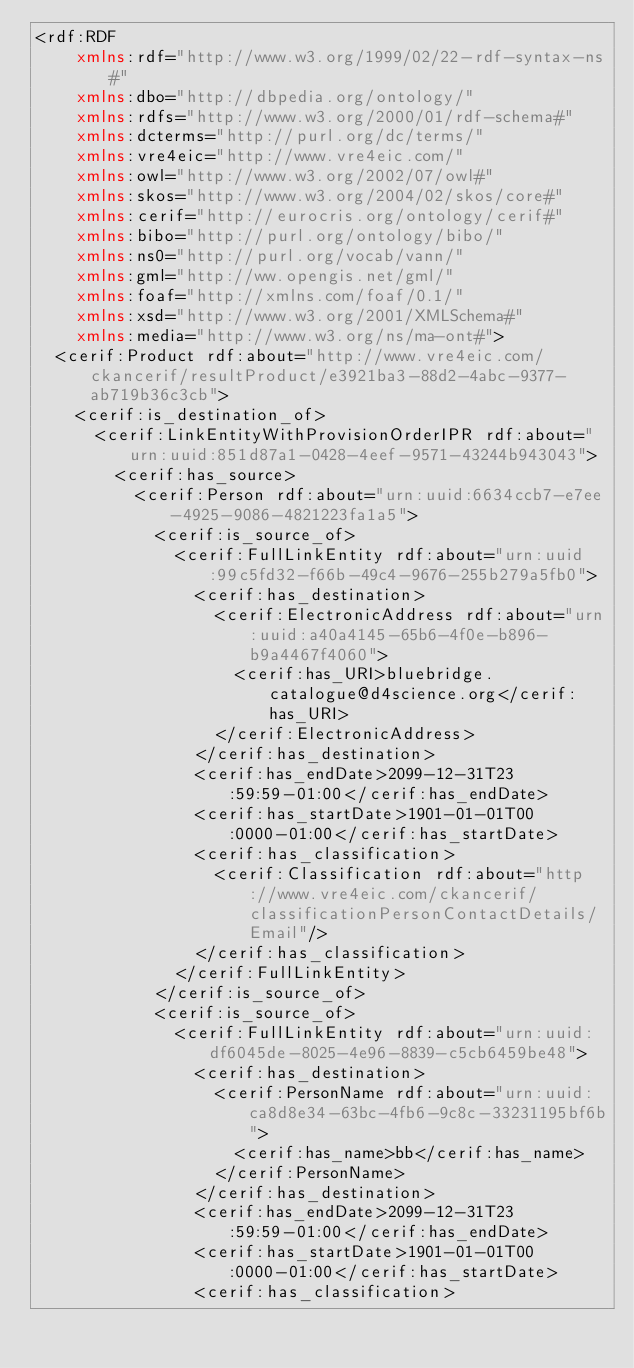<code> <loc_0><loc_0><loc_500><loc_500><_XML_><rdf:RDF
    xmlns:rdf="http://www.w3.org/1999/02/22-rdf-syntax-ns#"
    xmlns:dbo="http://dbpedia.org/ontology/"
    xmlns:rdfs="http://www.w3.org/2000/01/rdf-schema#"
    xmlns:dcterms="http://purl.org/dc/terms/"
    xmlns:vre4eic="http://www.vre4eic.com/"
    xmlns:owl="http://www.w3.org/2002/07/owl#"
    xmlns:skos="http://www.w3.org/2004/02/skos/core#"
    xmlns:cerif="http://eurocris.org/ontology/cerif#"
    xmlns:bibo="http://purl.org/ontology/bibo/"
    xmlns:ns0="http://purl.org/vocab/vann/"
    xmlns:gml="http://ww.opengis.net/gml/"
    xmlns:foaf="http://xmlns.com/foaf/0.1/"
    xmlns:xsd="http://www.w3.org/2001/XMLSchema#"
    xmlns:media="http://www.w3.org/ns/ma-ont#">
  <cerif:Product rdf:about="http://www.vre4eic.com/ckancerif/resultProduct/e3921ba3-88d2-4abc-9377-ab719b36c3cb">
    <cerif:is_destination_of>
      <cerif:LinkEntityWithProvisionOrderIPR rdf:about="urn:uuid:851d87a1-0428-4eef-9571-43244b943043">
        <cerif:has_source>
          <cerif:Person rdf:about="urn:uuid:6634ccb7-e7ee-4925-9086-4821223fa1a5">
            <cerif:is_source_of>
              <cerif:FullLinkEntity rdf:about="urn:uuid:99c5fd32-f66b-49c4-9676-255b279a5fb0">
                <cerif:has_destination>
                  <cerif:ElectronicAddress rdf:about="urn:uuid:a40a4145-65b6-4f0e-b896-b9a4467f4060">
                    <cerif:has_URI>bluebridge.catalogue@d4science.org</cerif:has_URI>
                  </cerif:ElectronicAddress>
                </cerif:has_destination>
                <cerif:has_endDate>2099-12-31T23:59:59-01:00</cerif:has_endDate>
                <cerif:has_startDate>1901-01-01T00:0000-01:00</cerif:has_startDate>
                <cerif:has_classification>
                  <cerif:Classification rdf:about="http://www.vre4eic.com/ckancerif/classificationPersonContactDetails/Email"/>
                </cerif:has_classification>
              </cerif:FullLinkEntity>
            </cerif:is_source_of>
            <cerif:is_source_of>
              <cerif:FullLinkEntity rdf:about="urn:uuid:df6045de-8025-4e96-8839-c5cb6459be48">
                <cerif:has_destination>
                  <cerif:PersonName rdf:about="urn:uuid:ca8d8e34-63bc-4fb6-9c8c-33231195bf6b">
                    <cerif:has_name>bb</cerif:has_name>
                  </cerif:PersonName>
                </cerif:has_destination>
                <cerif:has_endDate>2099-12-31T23:59:59-01:00</cerif:has_endDate>
                <cerif:has_startDate>1901-01-01T00:0000-01:00</cerif:has_startDate>
                <cerif:has_classification></code> 